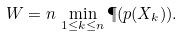<formula> <loc_0><loc_0><loc_500><loc_500>W = n \, \min _ { 1 \leq k \leq n } \P ( p ( X _ { k } ) ) .</formula> 